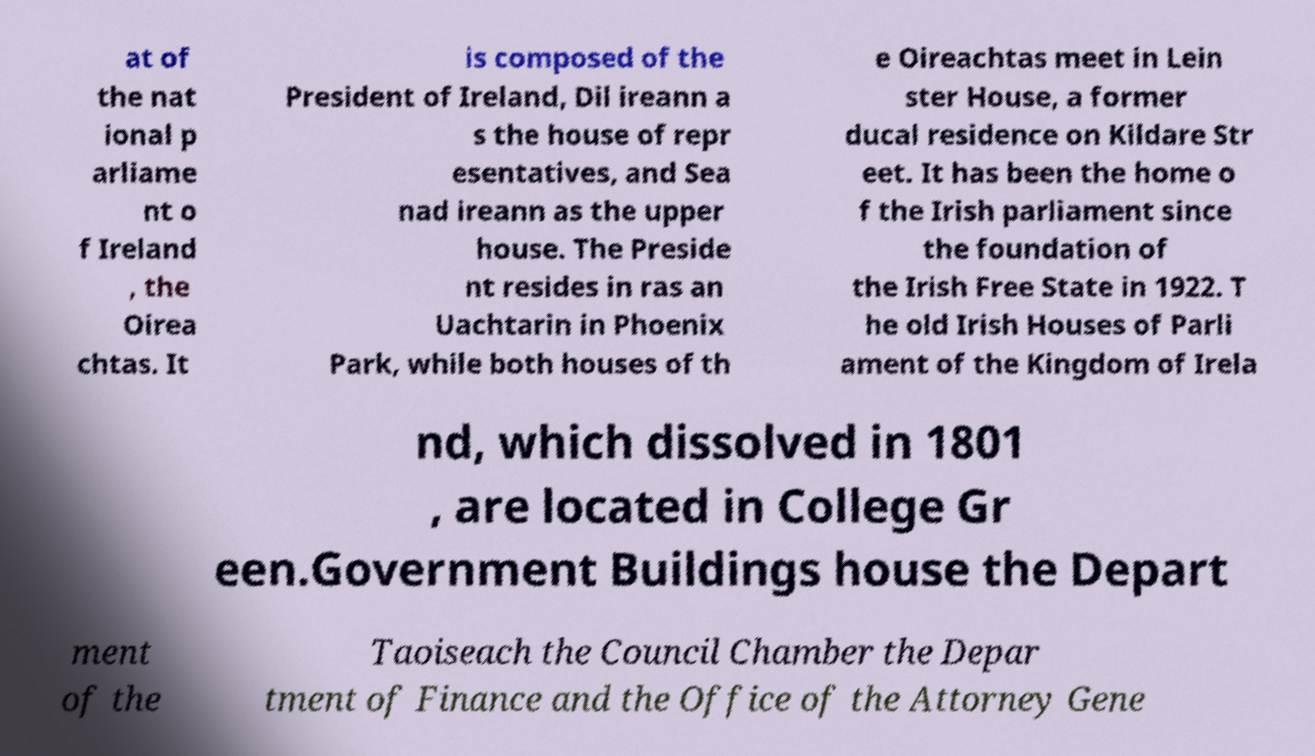Can you read and provide the text displayed in the image?This photo seems to have some interesting text. Can you extract and type it out for me? at of the nat ional p arliame nt o f Ireland , the Oirea chtas. It is composed of the President of Ireland, Dil ireann a s the house of repr esentatives, and Sea nad ireann as the upper house. The Preside nt resides in ras an Uachtarin in Phoenix Park, while both houses of th e Oireachtas meet in Lein ster House, a former ducal residence on Kildare Str eet. It has been the home o f the Irish parliament since the foundation of the Irish Free State in 1922. T he old Irish Houses of Parli ament of the Kingdom of Irela nd, which dissolved in 1801 , are located in College Gr een.Government Buildings house the Depart ment of the Taoiseach the Council Chamber the Depar tment of Finance and the Office of the Attorney Gene 